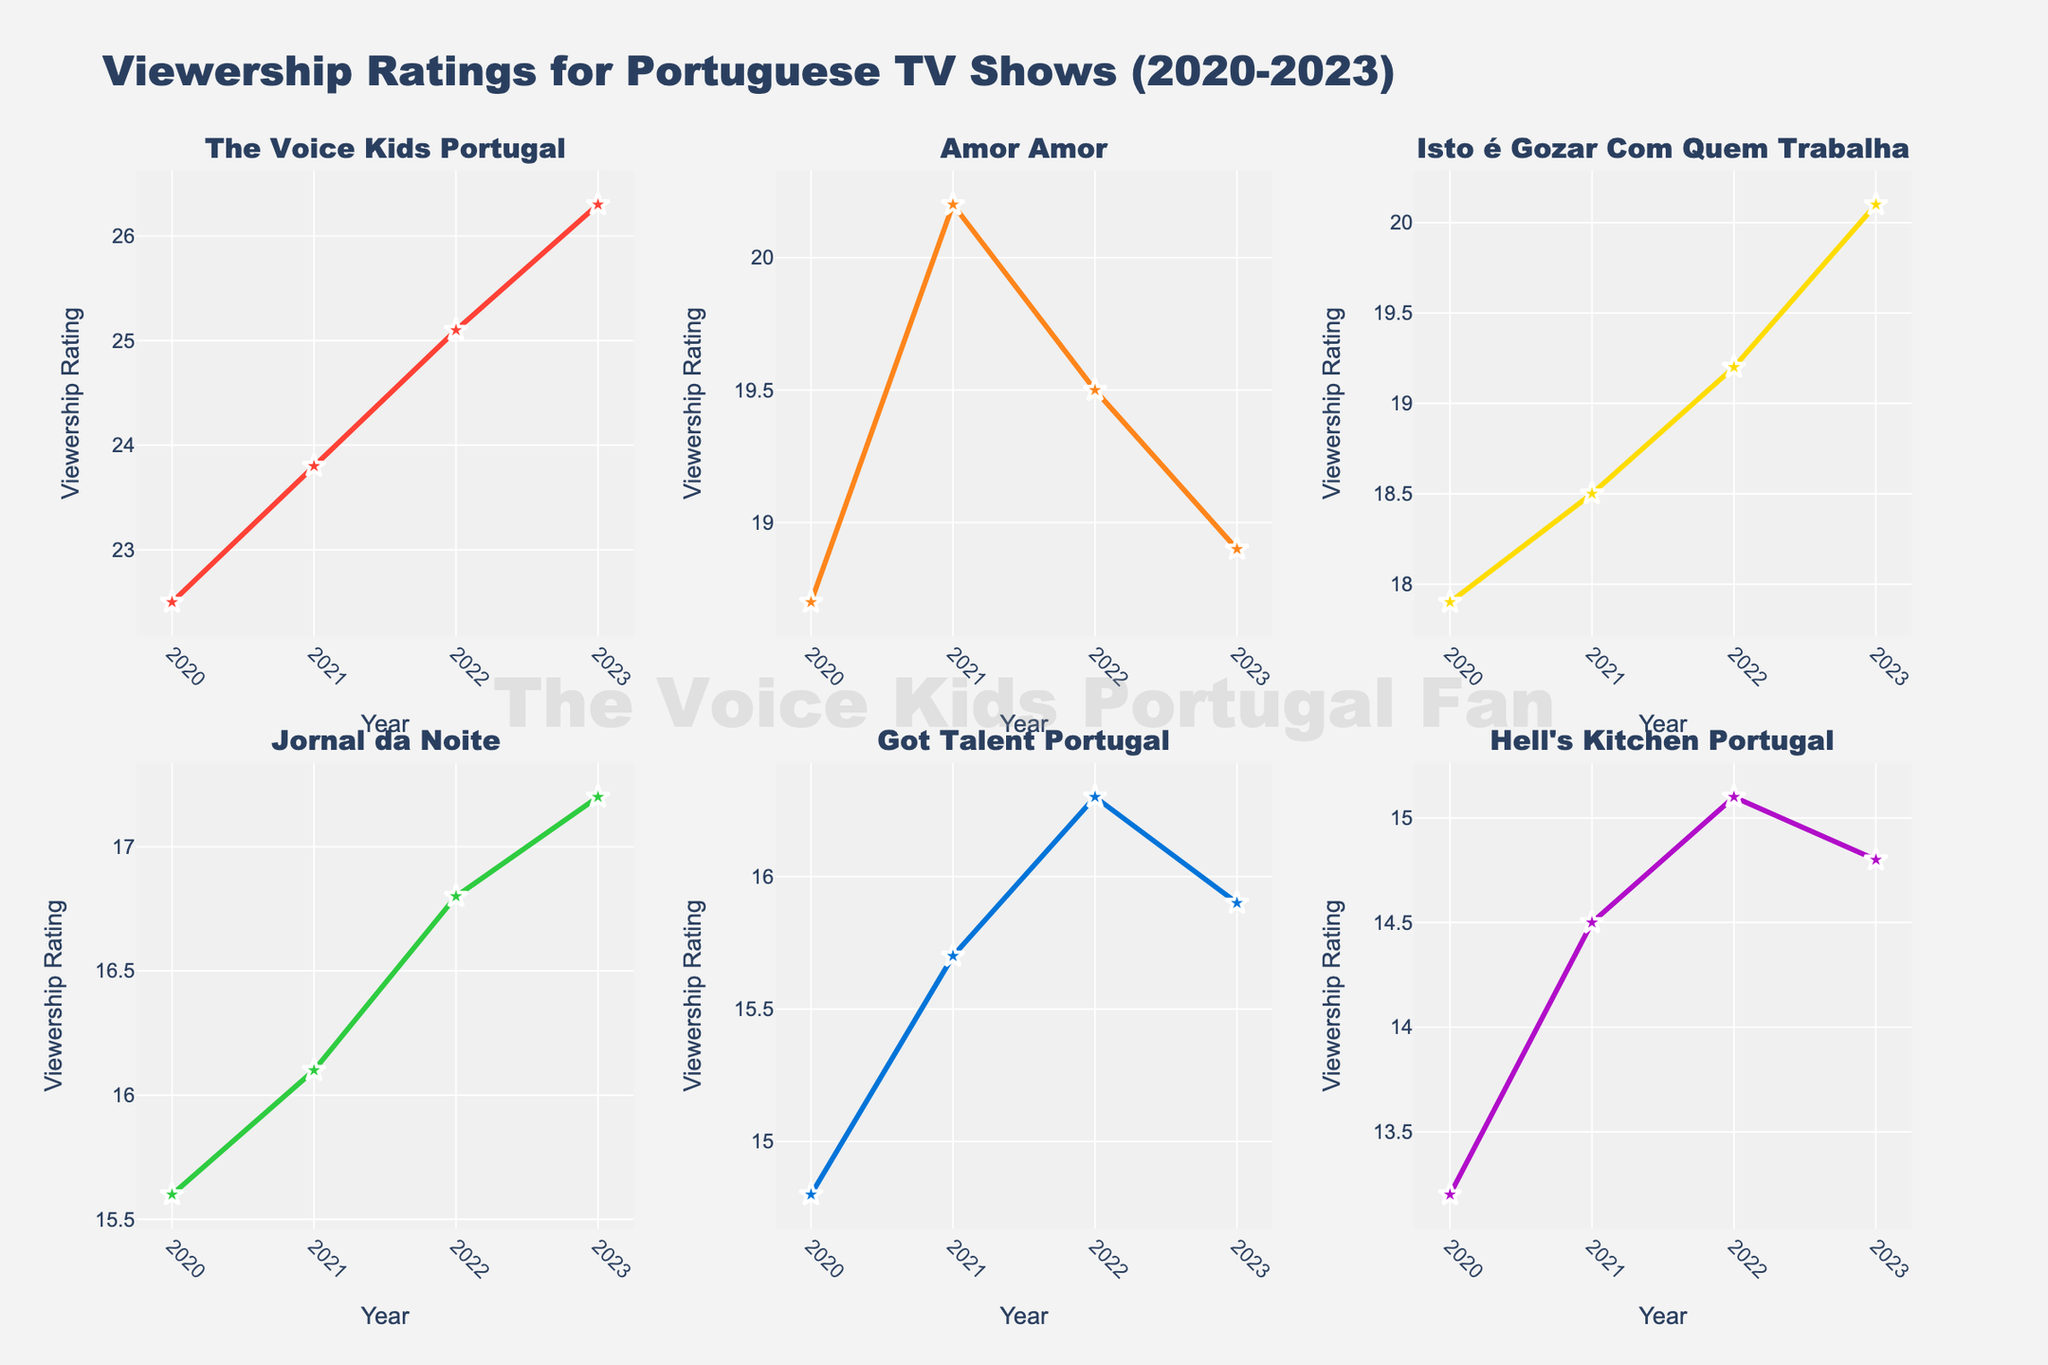What is the title of the figure? The title of the figure is written at the top and provides an overview of the data being presented. In this case, it is "Comparative Analysis of Literacy Rates in Eastern European Countries (1800-1950)."
Answer: Comparative Analysis of Literacy Rates in Eastern European Countries (1800-1950) What is the literacy rate of Russia in the year 1800? To find this, look at the horizontal subplot for Russia and refer to the data point corresponding to the year 1800.
Answer: 5% Which country had the highest literacy rate in 1950? Compare the literacy rates for all countries in their respective subplots at the year 1950.
Answer: Poland and Hungary What is the literacy rate trend of Romania from 1800 to 1950? Observe the Romania subplot and note how the literacy rate changes over time. The trend shows an increase from 3% in 1800 to 85% in 1950.
Answer: Increasing Between 1900 and 1925, which country experienced the largest increase in literacy rate? Compute the increase in literacy rates for each country between those years: Russia (30% to 55%), Poland (50% to 70%), Romania (25% to 45%), Hungary (45% to 85%), and Bulgaria (20% to 45%). Hungary experienced the largest increase.
Answer: Hungary How does the literacy rate of Bulgaria in 1850 compare with that in 1900? Look at the literacy rates of Bulgaria in the years 1850 and 1900, and compare them. In 1850, it is 8%, and in 1900, it is 20%.
Answer: It increased What is the average literacy rate of Hungary across all the years presented? To find the average, add the literacy rates for Hungary across all years and divide by the number of data points: (10 + 25 + 45 + 85 + 95) / 5.
Answer: 52% What is the difference in literacy rates between Poland and Romania in the year 1925? Compare the literacy rate of Poland in 1925 (70%) with that of Romania in the same year (45%). The difference is 70% - 45%.
Answer: 25% What color represents Russia in the figure? Check the specific color used in the subplot for Russia.
Answer: #FF6B6B (red) How many subplots are in the figure? Count the number of individual horizontal subplots, each representing a different country.
Answer: 5 